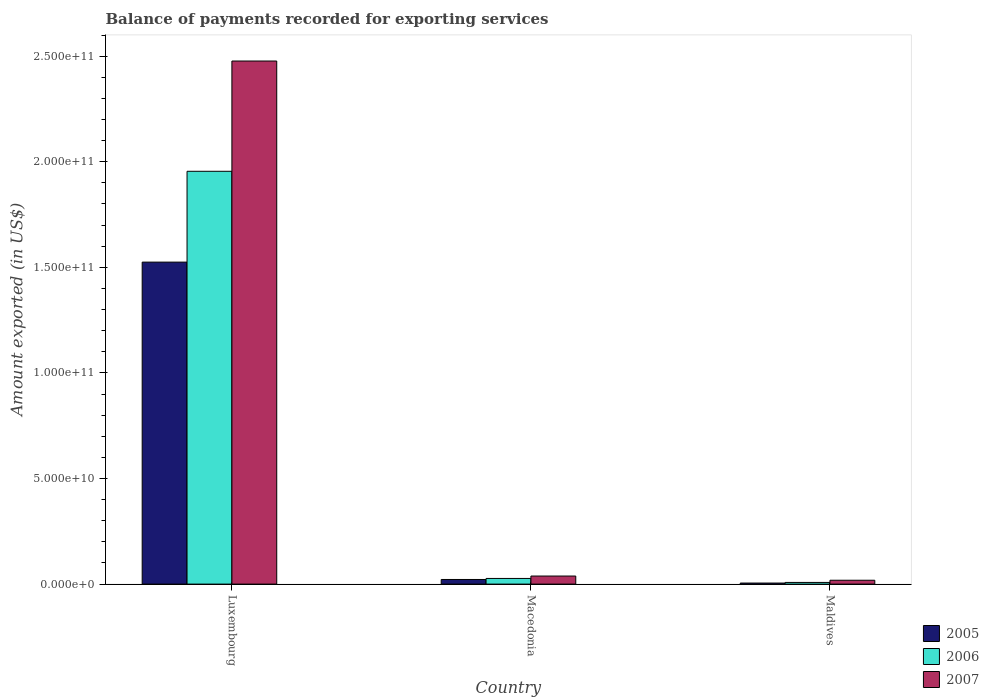How many groups of bars are there?
Offer a very short reply. 3. How many bars are there on the 1st tick from the right?
Your answer should be very brief. 3. What is the label of the 3rd group of bars from the left?
Ensure brevity in your answer.  Maldives. In how many cases, is the number of bars for a given country not equal to the number of legend labels?
Offer a very short reply. 0. What is the amount exported in 2006 in Macedonia?
Your response must be concise. 2.68e+09. Across all countries, what is the maximum amount exported in 2007?
Your response must be concise. 2.48e+11. Across all countries, what is the minimum amount exported in 2007?
Offer a terse response. 1.83e+09. In which country was the amount exported in 2006 maximum?
Offer a terse response. Luxembourg. In which country was the amount exported in 2005 minimum?
Offer a very short reply. Maldives. What is the total amount exported in 2006 in the graph?
Provide a short and direct response. 1.99e+11. What is the difference between the amount exported in 2005 in Macedonia and that in Maldives?
Offer a very short reply. 1.69e+09. What is the difference between the amount exported in 2005 in Maldives and the amount exported in 2007 in Luxembourg?
Offer a very short reply. -2.47e+11. What is the average amount exported in 2007 per country?
Your answer should be compact. 8.44e+1. What is the difference between the amount exported of/in 2007 and amount exported of/in 2006 in Macedonia?
Give a very brief answer. 1.14e+09. What is the ratio of the amount exported in 2005 in Luxembourg to that in Macedonia?
Give a very brief answer. 69.63. What is the difference between the highest and the second highest amount exported in 2005?
Ensure brevity in your answer.  1.69e+09. What is the difference between the highest and the lowest amount exported in 2005?
Your answer should be very brief. 1.52e+11. Is the sum of the amount exported in 2006 in Luxembourg and Macedonia greater than the maximum amount exported in 2005 across all countries?
Ensure brevity in your answer.  Yes. What does the 2nd bar from the left in Maldives represents?
Offer a very short reply. 2006. What does the 3rd bar from the right in Macedonia represents?
Offer a terse response. 2005. Is it the case that in every country, the sum of the amount exported in 2006 and amount exported in 2005 is greater than the amount exported in 2007?
Ensure brevity in your answer.  No. How many bars are there?
Your answer should be compact. 9. What is the difference between two consecutive major ticks on the Y-axis?
Offer a very short reply. 5.00e+1. Does the graph contain any zero values?
Make the answer very short. No. How many legend labels are there?
Ensure brevity in your answer.  3. What is the title of the graph?
Your answer should be compact. Balance of payments recorded for exporting services. Does "1965" appear as one of the legend labels in the graph?
Keep it short and to the point. No. What is the label or title of the Y-axis?
Your answer should be compact. Amount exported (in US$). What is the Amount exported (in US$) in 2005 in Luxembourg?
Provide a short and direct response. 1.52e+11. What is the Amount exported (in US$) of 2006 in Luxembourg?
Ensure brevity in your answer.  1.95e+11. What is the Amount exported (in US$) in 2007 in Luxembourg?
Provide a short and direct response. 2.48e+11. What is the Amount exported (in US$) of 2005 in Macedonia?
Give a very brief answer. 2.19e+09. What is the Amount exported (in US$) of 2006 in Macedonia?
Your answer should be compact. 2.68e+09. What is the Amount exported (in US$) in 2007 in Macedonia?
Your answer should be compact. 3.82e+09. What is the Amount exported (in US$) of 2005 in Maldives?
Offer a terse response. 4.95e+08. What is the Amount exported (in US$) in 2006 in Maldives?
Provide a succinct answer. 7.93e+08. What is the Amount exported (in US$) in 2007 in Maldives?
Give a very brief answer. 1.83e+09. Across all countries, what is the maximum Amount exported (in US$) in 2005?
Offer a terse response. 1.52e+11. Across all countries, what is the maximum Amount exported (in US$) in 2006?
Provide a succinct answer. 1.95e+11. Across all countries, what is the maximum Amount exported (in US$) of 2007?
Keep it short and to the point. 2.48e+11. Across all countries, what is the minimum Amount exported (in US$) in 2005?
Make the answer very short. 4.95e+08. Across all countries, what is the minimum Amount exported (in US$) of 2006?
Provide a short and direct response. 7.93e+08. Across all countries, what is the minimum Amount exported (in US$) in 2007?
Offer a terse response. 1.83e+09. What is the total Amount exported (in US$) of 2005 in the graph?
Give a very brief answer. 1.55e+11. What is the total Amount exported (in US$) of 2006 in the graph?
Provide a short and direct response. 1.99e+11. What is the total Amount exported (in US$) of 2007 in the graph?
Give a very brief answer. 2.53e+11. What is the difference between the Amount exported (in US$) of 2005 in Luxembourg and that in Macedonia?
Your answer should be very brief. 1.50e+11. What is the difference between the Amount exported (in US$) of 2006 in Luxembourg and that in Macedonia?
Offer a terse response. 1.93e+11. What is the difference between the Amount exported (in US$) of 2007 in Luxembourg and that in Macedonia?
Your answer should be compact. 2.44e+11. What is the difference between the Amount exported (in US$) of 2005 in Luxembourg and that in Maldives?
Give a very brief answer. 1.52e+11. What is the difference between the Amount exported (in US$) of 2006 in Luxembourg and that in Maldives?
Offer a terse response. 1.95e+11. What is the difference between the Amount exported (in US$) in 2007 in Luxembourg and that in Maldives?
Keep it short and to the point. 2.46e+11. What is the difference between the Amount exported (in US$) of 2005 in Macedonia and that in Maldives?
Offer a terse response. 1.69e+09. What is the difference between the Amount exported (in US$) of 2006 in Macedonia and that in Maldives?
Provide a short and direct response. 1.89e+09. What is the difference between the Amount exported (in US$) of 2007 in Macedonia and that in Maldives?
Provide a succinct answer. 1.99e+09. What is the difference between the Amount exported (in US$) of 2005 in Luxembourg and the Amount exported (in US$) of 2006 in Macedonia?
Keep it short and to the point. 1.50e+11. What is the difference between the Amount exported (in US$) in 2005 in Luxembourg and the Amount exported (in US$) in 2007 in Macedonia?
Ensure brevity in your answer.  1.49e+11. What is the difference between the Amount exported (in US$) of 2006 in Luxembourg and the Amount exported (in US$) of 2007 in Macedonia?
Give a very brief answer. 1.92e+11. What is the difference between the Amount exported (in US$) of 2005 in Luxembourg and the Amount exported (in US$) of 2006 in Maldives?
Your answer should be very brief. 1.52e+11. What is the difference between the Amount exported (in US$) of 2005 in Luxembourg and the Amount exported (in US$) of 2007 in Maldives?
Your response must be concise. 1.51e+11. What is the difference between the Amount exported (in US$) of 2006 in Luxembourg and the Amount exported (in US$) of 2007 in Maldives?
Your answer should be very brief. 1.94e+11. What is the difference between the Amount exported (in US$) in 2005 in Macedonia and the Amount exported (in US$) in 2006 in Maldives?
Offer a very short reply. 1.40e+09. What is the difference between the Amount exported (in US$) of 2005 in Macedonia and the Amount exported (in US$) of 2007 in Maldives?
Offer a very short reply. 3.59e+08. What is the difference between the Amount exported (in US$) of 2006 in Macedonia and the Amount exported (in US$) of 2007 in Maldives?
Provide a succinct answer. 8.48e+08. What is the average Amount exported (in US$) in 2005 per country?
Your answer should be compact. 5.17e+1. What is the average Amount exported (in US$) of 2006 per country?
Offer a terse response. 6.63e+1. What is the average Amount exported (in US$) of 2007 per country?
Provide a short and direct response. 8.44e+1. What is the difference between the Amount exported (in US$) of 2005 and Amount exported (in US$) of 2006 in Luxembourg?
Ensure brevity in your answer.  -4.30e+1. What is the difference between the Amount exported (in US$) in 2005 and Amount exported (in US$) in 2007 in Luxembourg?
Offer a terse response. -9.52e+1. What is the difference between the Amount exported (in US$) in 2006 and Amount exported (in US$) in 2007 in Luxembourg?
Provide a short and direct response. -5.22e+1. What is the difference between the Amount exported (in US$) of 2005 and Amount exported (in US$) of 2006 in Macedonia?
Your answer should be compact. -4.89e+08. What is the difference between the Amount exported (in US$) of 2005 and Amount exported (in US$) of 2007 in Macedonia?
Provide a short and direct response. -1.63e+09. What is the difference between the Amount exported (in US$) in 2006 and Amount exported (in US$) in 2007 in Macedonia?
Provide a succinct answer. -1.14e+09. What is the difference between the Amount exported (in US$) in 2005 and Amount exported (in US$) in 2006 in Maldives?
Make the answer very short. -2.97e+08. What is the difference between the Amount exported (in US$) of 2005 and Amount exported (in US$) of 2007 in Maldives?
Your response must be concise. -1.34e+09. What is the difference between the Amount exported (in US$) in 2006 and Amount exported (in US$) in 2007 in Maldives?
Provide a succinct answer. -1.04e+09. What is the ratio of the Amount exported (in US$) in 2005 in Luxembourg to that in Macedonia?
Offer a very short reply. 69.63. What is the ratio of the Amount exported (in US$) of 2006 in Luxembourg to that in Macedonia?
Your response must be concise. 72.98. What is the ratio of the Amount exported (in US$) in 2007 in Luxembourg to that in Macedonia?
Your answer should be very brief. 64.83. What is the ratio of the Amount exported (in US$) of 2005 in Luxembourg to that in Maldives?
Offer a very short reply. 307.8. What is the ratio of the Amount exported (in US$) in 2006 in Luxembourg to that in Maldives?
Provide a succinct answer. 246.61. What is the ratio of the Amount exported (in US$) of 2007 in Luxembourg to that in Maldives?
Your answer should be compact. 135.31. What is the ratio of the Amount exported (in US$) of 2005 in Macedonia to that in Maldives?
Provide a succinct answer. 4.42. What is the ratio of the Amount exported (in US$) of 2006 in Macedonia to that in Maldives?
Your answer should be very brief. 3.38. What is the ratio of the Amount exported (in US$) of 2007 in Macedonia to that in Maldives?
Offer a terse response. 2.09. What is the difference between the highest and the second highest Amount exported (in US$) in 2005?
Make the answer very short. 1.50e+11. What is the difference between the highest and the second highest Amount exported (in US$) of 2006?
Offer a very short reply. 1.93e+11. What is the difference between the highest and the second highest Amount exported (in US$) of 2007?
Provide a succinct answer. 2.44e+11. What is the difference between the highest and the lowest Amount exported (in US$) of 2005?
Your response must be concise. 1.52e+11. What is the difference between the highest and the lowest Amount exported (in US$) in 2006?
Keep it short and to the point. 1.95e+11. What is the difference between the highest and the lowest Amount exported (in US$) of 2007?
Your answer should be very brief. 2.46e+11. 